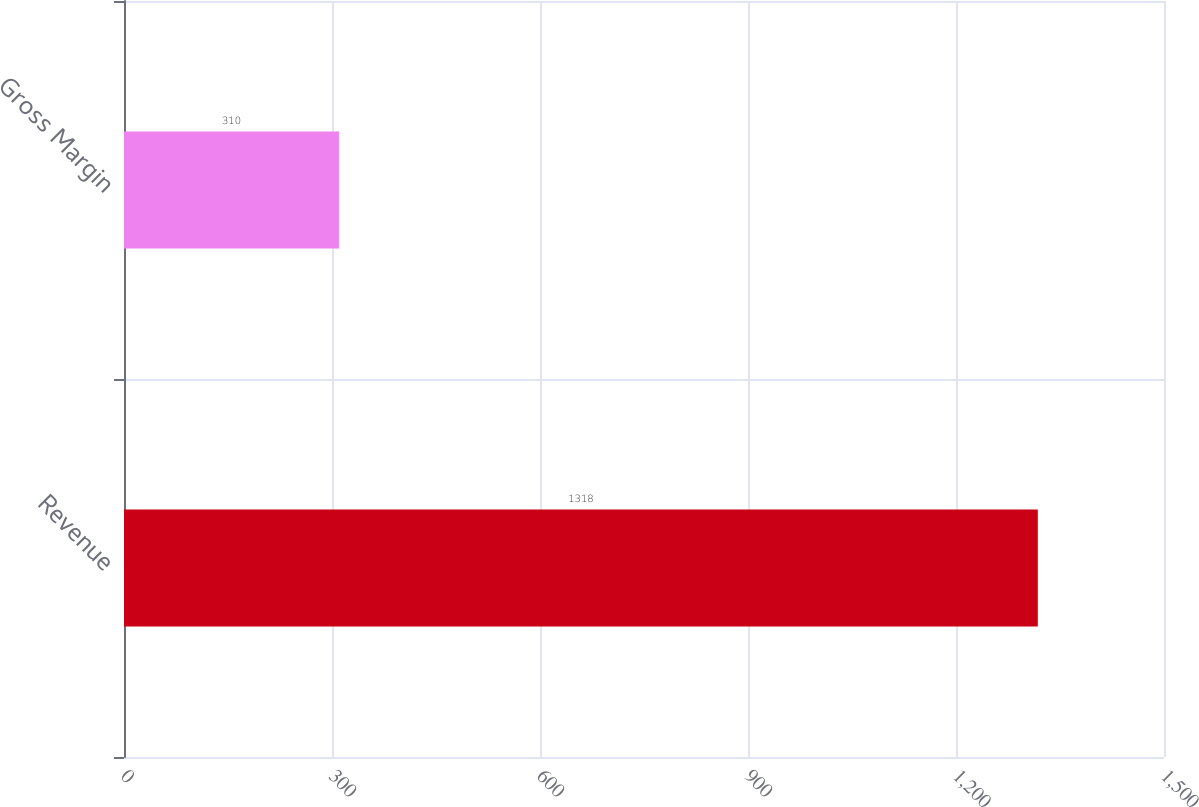Convert chart. <chart><loc_0><loc_0><loc_500><loc_500><bar_chart><fcel>Revenue<fcel>Gross Margin<nl><fcel>1318<fcel>310<nl></chart> 